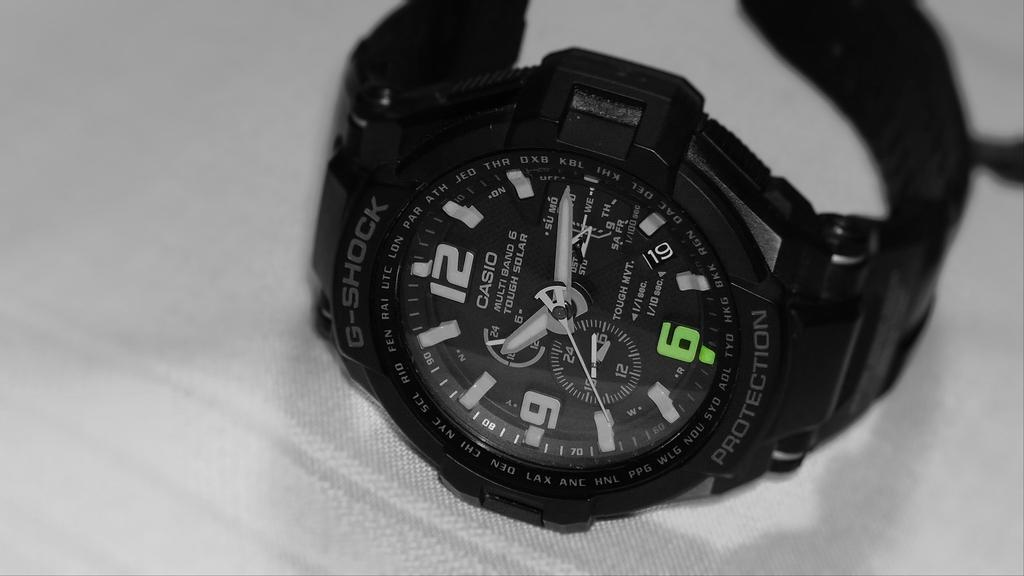<image>
Render a clear and concise summary of the photo. A black and white watch with the words Tough MVT written near the center. 